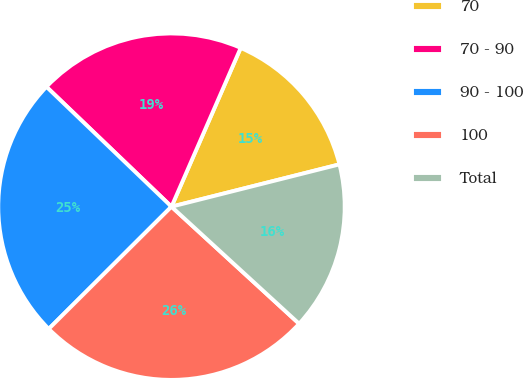<chart> <loc_0><loc_0><loc_500><loc_500><pie_chart><fcel>70<fcel>70 - 90<fcel>90 - 100<fcel>100<fcel>Total<nl><fcel>14.53%<fcel>19.38%<fcel>24.63%<fcel>25.72%<fcel>15.74%<nl></chart> 